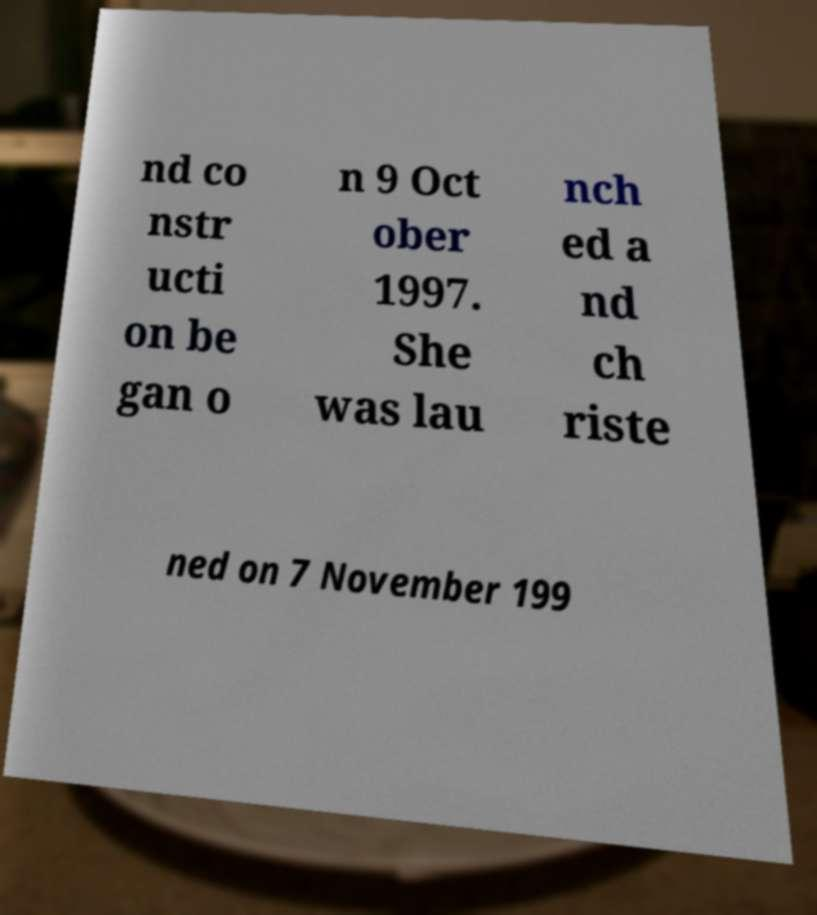Could you extract and type out the text from this image? nd co nstr ucti on be gan o n 9 Oct ober 1997. She was lau nch ed a nd ch riste ned on 7 November 199 